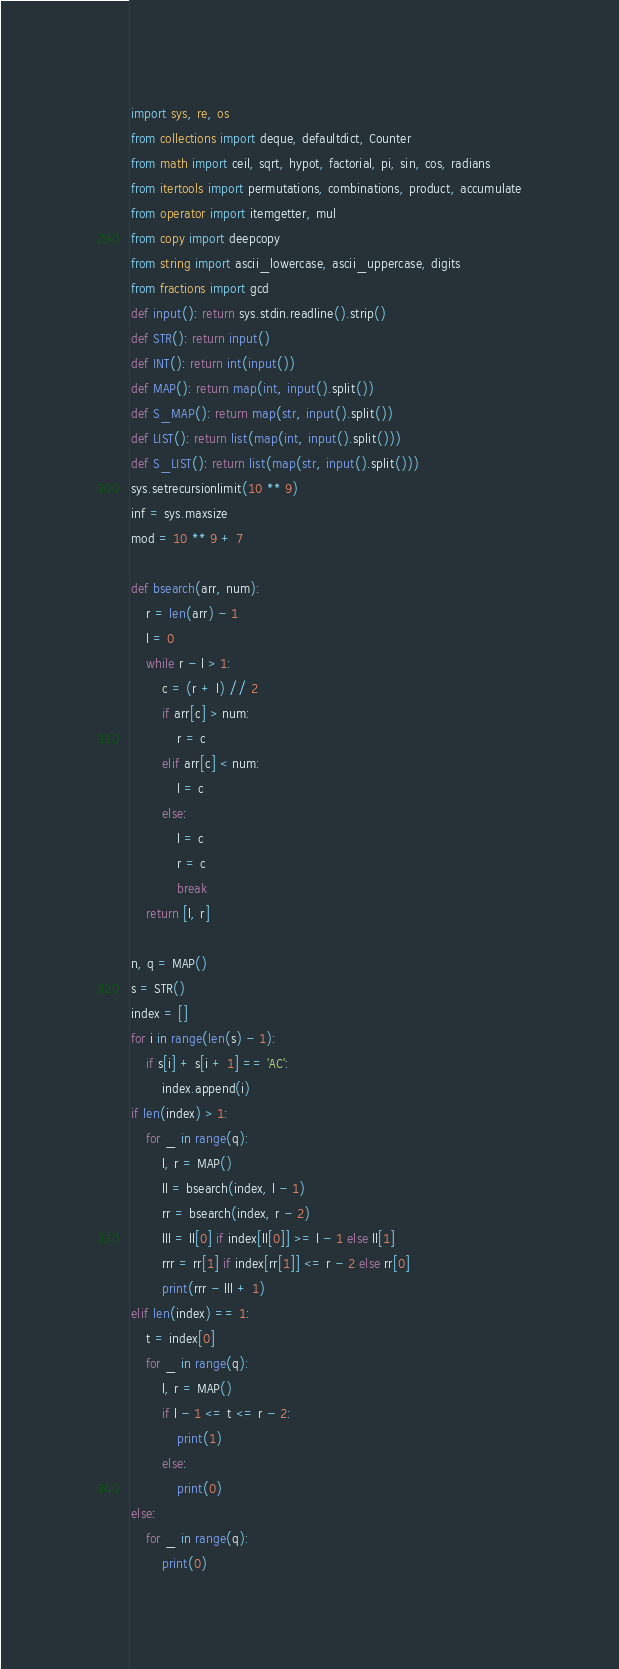<code> <loc_0><loc_0><loc_500><loc_500><_Python_>import sys, re, os
from collections import deque, defaultdict, Counter
from math import ceil, sqrt, hypot, factorial, pi, sin, cos, radians
from itertools import permutations, combinations, product, accumulate
from operator import itemgetter, mul
from copy import deepcopy
from string import ascii_lowercase, ascii_uppercase, digits
from fractions import gcd
def input(): return sys.stdin.readline().strip()
def STR(): return input()
def INT(): return int(input())
def MAP(): return map(int, input().split())
def S_MAP(): return map(str, input().split())
def LIST(): return list(map(int, input().split()))
def S_LIST(): return list(map(str, input().split()))
sys.setrecursionlimit(10 ** 9)
inf = sys.maxsize
mod = 10 ** 9 + 7

def bsearch(arr, num):
    r = len(arr) - 1
    l = 0
    while r - l > 1:
        c = (r + l) // 2
        if arr[c] > num:
            r = c
        elif arr[c] < num:
            l = c
        else:
            l = c
            r = c
            break
    return [l, r]

n, q = MAP()
s = STR()
index = []
for i in range(len(s) - 1):
    if s[i] + s[i + 1] == 'AC':
        index.append(i)
if len(index) > 1:
    for _ in range(q):
        l, r = MAP()
        ll = bsearch(index, l - 1)
        rr = bsearch(index, r - 2)
        lll = ll[0] if index[ll[0]] >= l - 1 else ll[1]
        rrr = rr[1] if index[rr[1]] <= r - 2 else rr[0]
        print(rrr - lll + 1)
elif len(index) == 1:
    t = index[0]
    for _ in range(q):
        l, r = MAP()
        if l - 1 <= t <= r - 2:
            print(1)
        else:
            print(0)
else:
    for _ in range(q):
        print(0)
</code> 